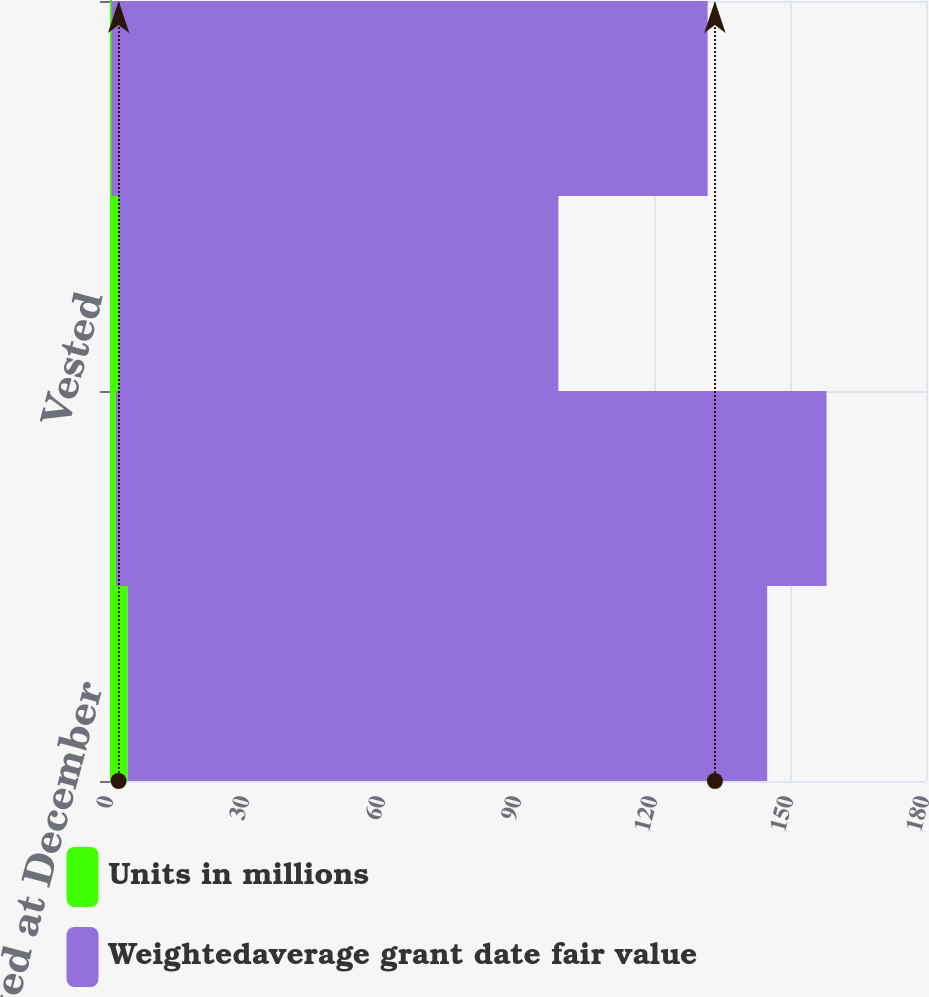Convert chart. <chart><loc_0><loc_0><loc_500><loc_500><stacked_bar_chart><ecel><fcel>Balance nonvested at December<fcel>Granted<fcel>Vested<fcel>Forfeited<nl><fcel>Units in millions<fcel>3.9<fcel>1.3<fcel>2<fcel>0.4<nl><fcel>Weightedaverage grant date fair value<fcel>141.07<fcel>156.76<fcel>96.91<fcel>131.43<nl></chart> 